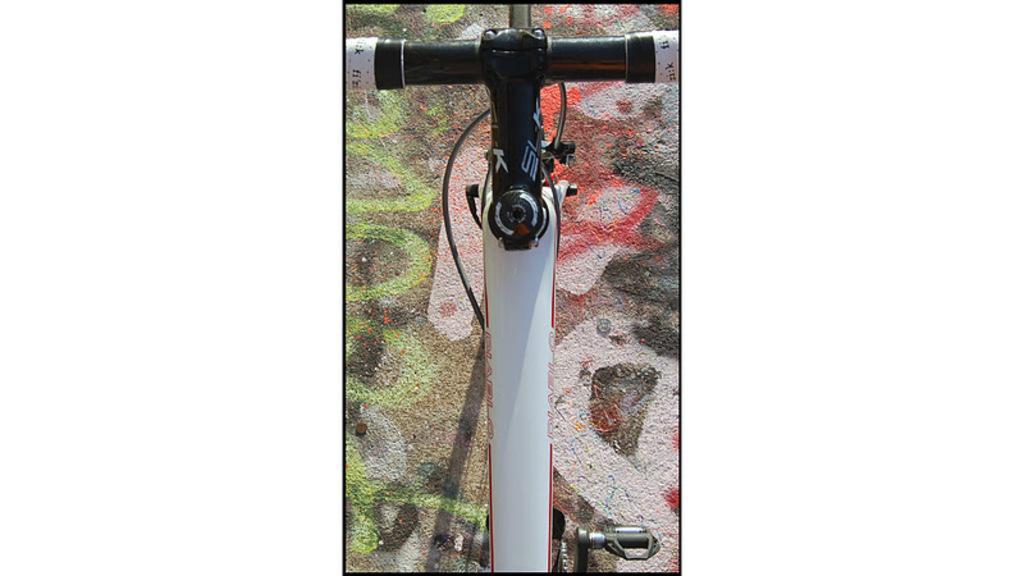Describe this image in one or two sentences. In this image we can see a bicycle on the floor. 